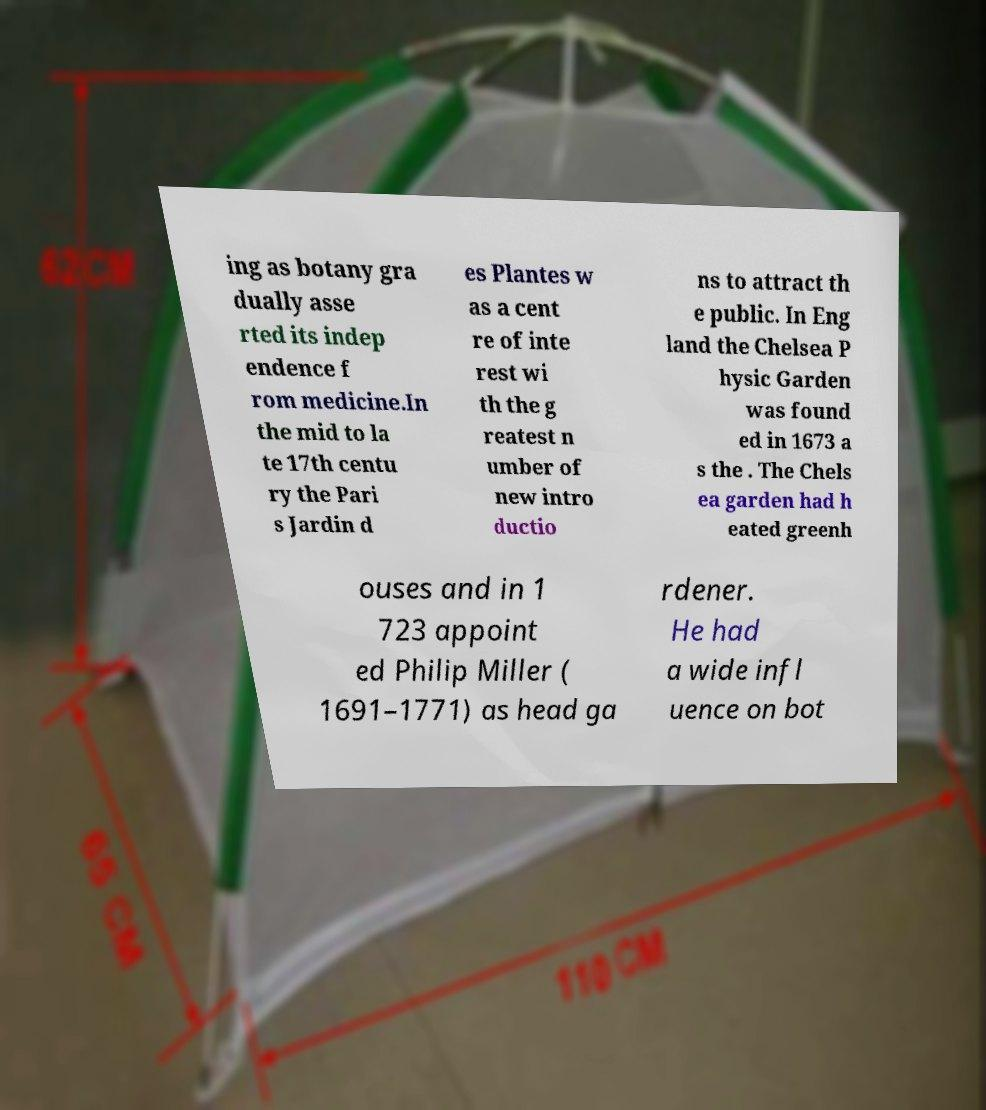Please identify and transcribe the text found in this image. ing as botany gra dually asse rted its indep endence f rom medicine.In the mid to la te 17th centu ry the Pari s Jardin d es Plantes w as a cent re of inte rest wi th the g reatest n umber of new intro ductio ns to attract th e public. In Eng land the Chelsea P hysic Garden was found ed in 1673 a s the . The Chels ea garden had h eated greenh ouses and in 1 723 appoint ed Philip Miller ( 1691–1771) as head ga rdener. He had a wide infl uence on bot 